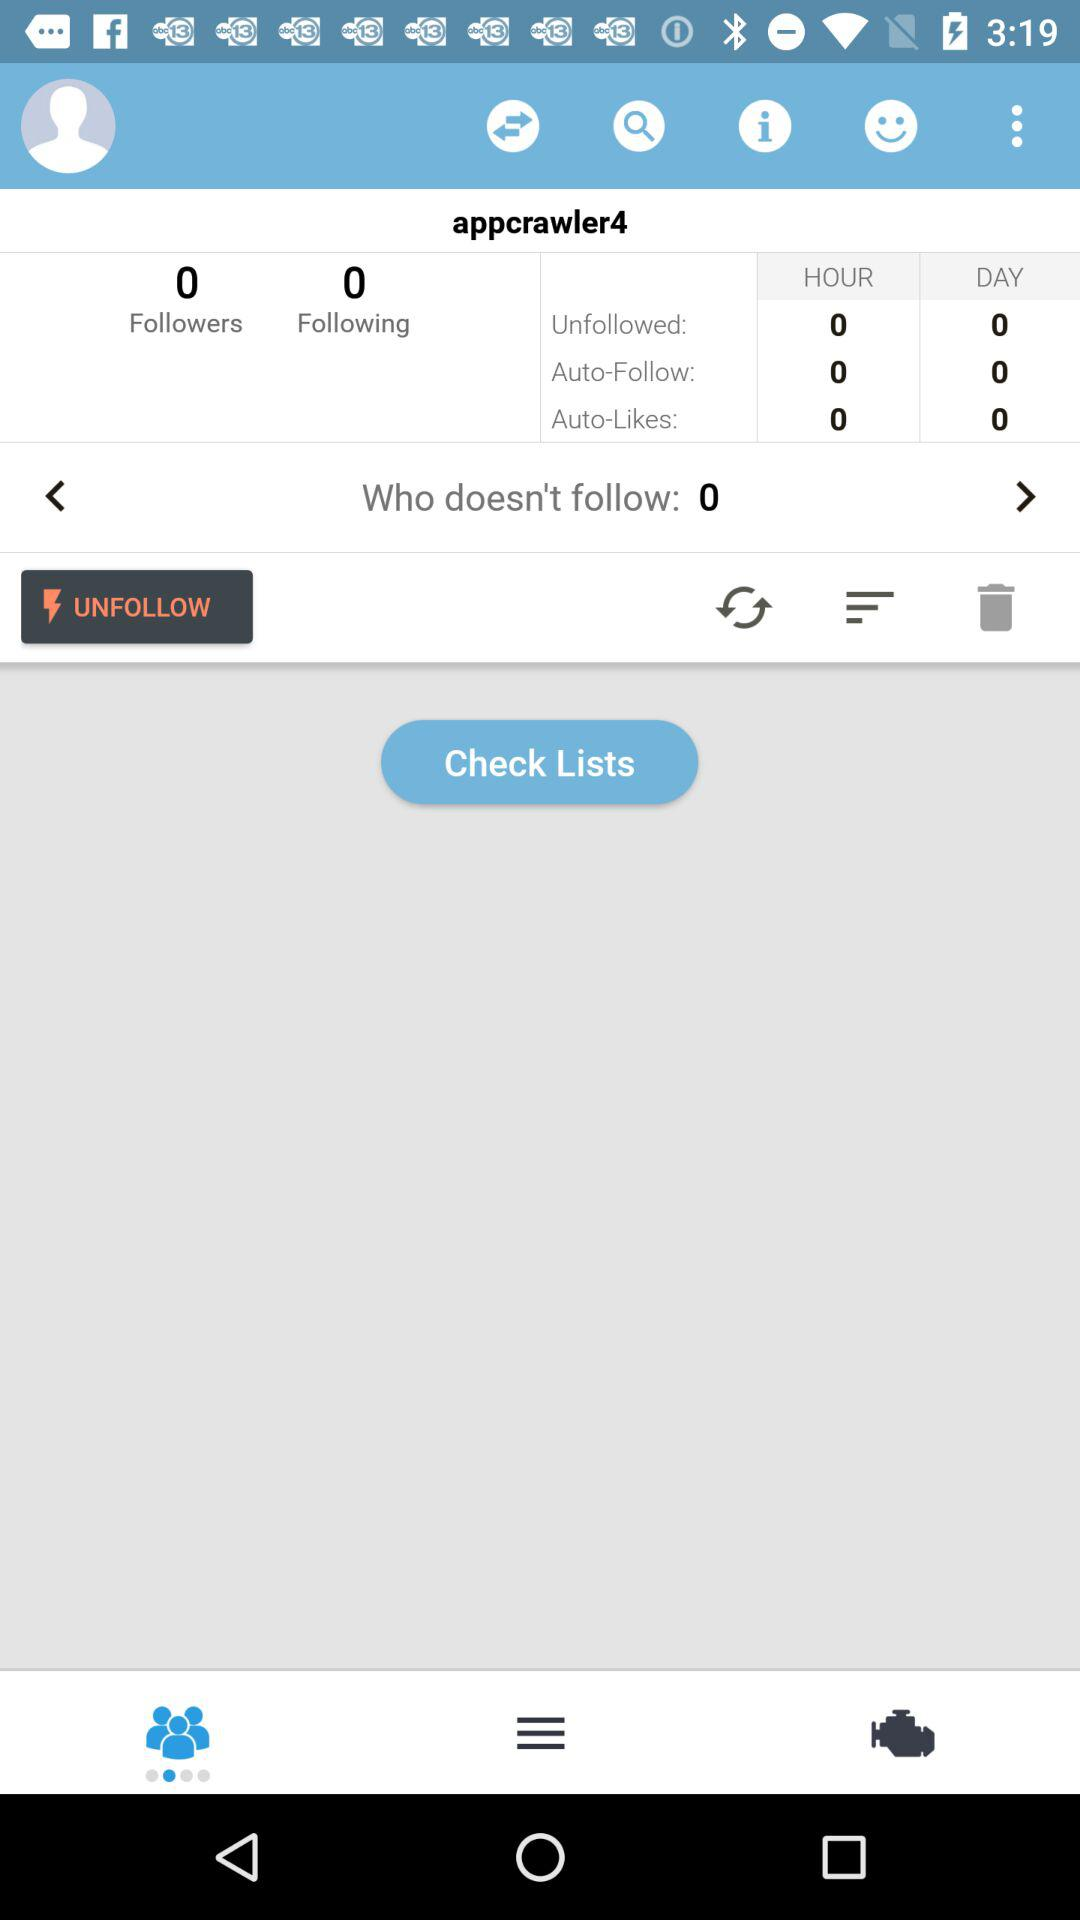What is the login name? The login name is "appcrawler4". 